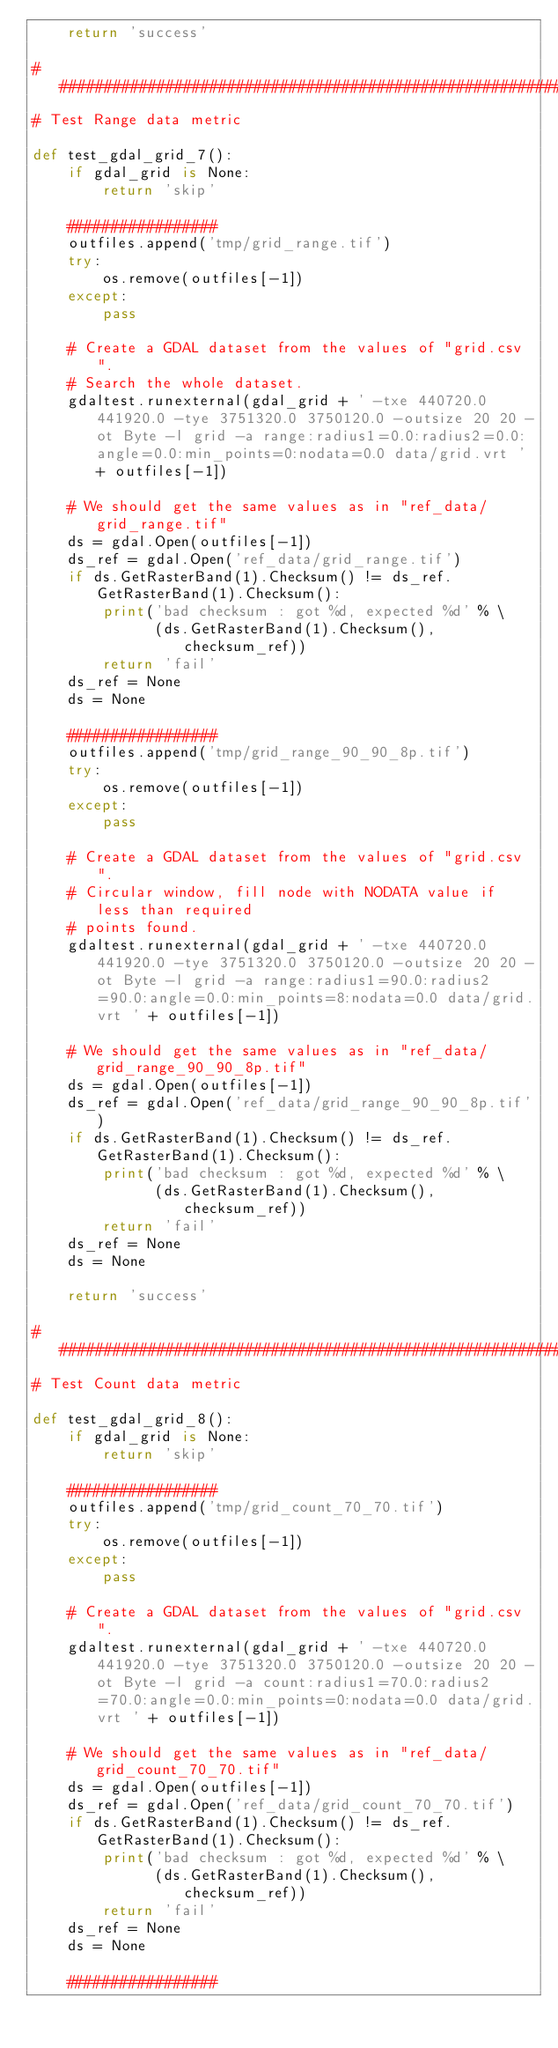Convert code to text. <code><loc_0><loc_0><loc_500><loc_500><_Python_>    return 'success'

###############################################################################
# Test Range data metric

def test_gdal_grid_7():
    if gdal_grid is None:
        return 'skip'

    #################
    outfiles.append('tmp/grid_range.tif')
    try:
        os.remove(outfiles[-1])
    except:
        pass

    # Create a GDAL dataset from the values of "grid.csv".
    # Search the whole dataset.
    gdaltest.runexternal(gdal_grid + ' -txe 440720.0 441920.0 -tye 3751320.0 3750120.0 -outsize 20 20 -ot Byte -l grid -a range:radius1=0.0:radius2=0.0:angle=0.0:min_points=0:nodata=0.0 data/grid.vrt ' + outfiles[-1])

    # We should get the same values as in "ref_data/grid_range.tif"
    ds = gdal.Open(outfiles[-1])
    ds_ref = gdal.Open('ref_data/grid_range.tif')
    if ds.GetRasterBand(1).Checksum() != ds_ref.GetRasterBand(1).Checksum():
        print('bad checksum : got %d, expected %d' % \
              (ds.GetRasterBand(1).Checksum(), checksum_ref))
        return 'fail'
    ds_ref = None
    ds = None

    #################
    outfiles.append('tmp/grid_range_90_90_8p.tif')
    try:
        os.remove(outfiles[-1])
    except:
        pass

    # Create a GDAL dataset from the values of "grid.csv".
    # Circular window, fill node with NODATA value if less than required
    # points found.
    gdaltest.runexternal(gdal_grid + ' -txe 440720.0 441920.0 -tye 3751320.0 3750120.0 -outsize 20 20 -ot Byte -l grid -a range:radius1=90.0:radius2=90.0:angle=0.0:min_points=8:nodata=0.0 data/grid.vrt ' + outfiles[-1])

    # We should get the same values as in "ref_data/grid_range_90_90_8p.tif"
    ds = gdal.Open(outfiles[-1])
    ds_ref = gdal.Open('ref_data/grid_range_90_90_8p.tif')
    if ds.GetRasterBand(1).Checksum() != ds_ref.GetRasterBand(1).Checksum():
        print('bad checksum : got %d, expected %d' % \
              (ds.GetRasterBand(1).Checksum(), checksum_ref))
        return 'fail'
    ds_ref = None
    ds = None

    return 'success'

###############################################################################
# Test Count data metric

def test_gdal_grid_8():
    if gdal_grid is None:
        return 'skip'

    #################
    outfiles.append('tmp/grid_count_70_70.tif')
    try:
        os.remove(outfiles[-1])
    except:
        pass

    # Create a GDAL dataset from the values of "grid.csv".
    gdaltest.runexternal(gdal_grid + ' -txe 440720.0 441920.0 -tye 3751320.0 3750120.0 -outsize 20 20 -ot Byte -l grid -a count:radius1=70.0:radius2=70.0:angle=0.0:min_points=0:nodata=0.0 data/grid.vrt ' + outfiles[-1])

    # We should get the same values as in "ref_data/grid_count_70_70.tif"
    ds = gdal.Open(outfiles[-1])
    ds_ref = gdal.Open('ref_data/grid_count_70_70.tif')
    if ds.GetRasterBand(1).Checksum() != ds_ref.GetRasterBand(1).Checksum():
        print('bad checksum : got %d, expected %d' % \
              (ds.GetRasterBand(1).Checksum(), checksum_ref))
        return 'fail'
    ds_ref = None
    ds = None

    #################</code> 